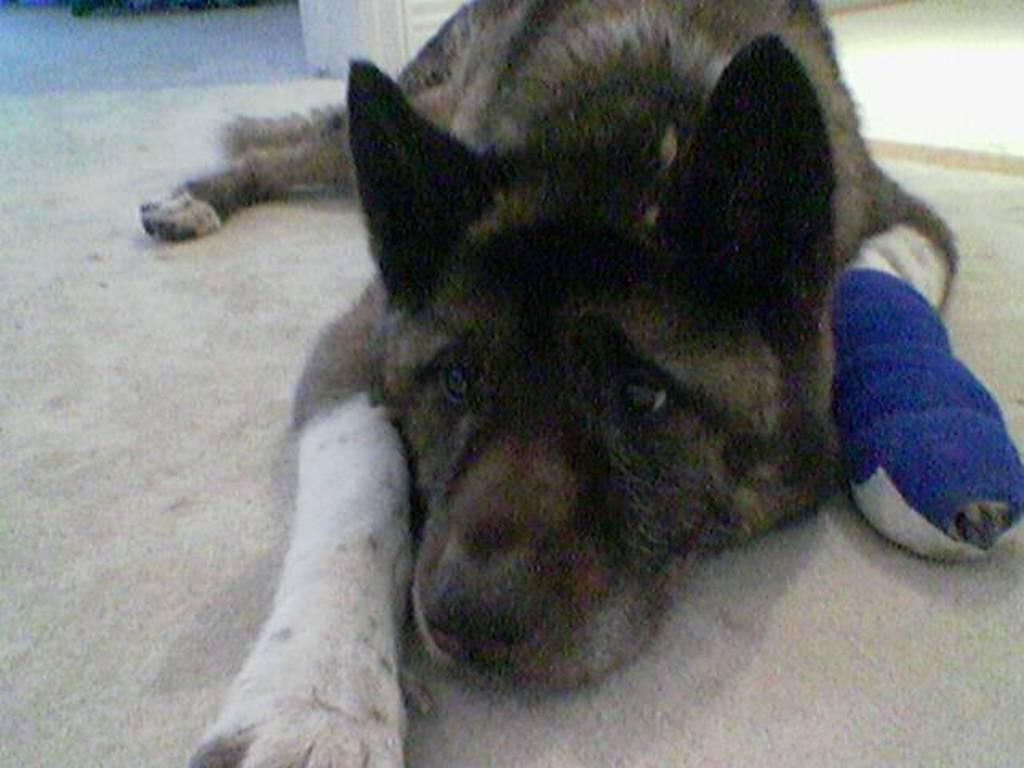What animal is present in the image? There is a dog in the image. What surface is the dog situated on? The dog is on a carpet. Does the dog have any visible medical treatment in the image? Yes, the dog has a bandage on its leg. What type of instrument is the dog playing in the image? There is no instrument present in the image, and the dog is not playing any instrument. What edge is visible in the image? There is no specific edge mentioned in the provided facts, and the image does not depict any edges. 